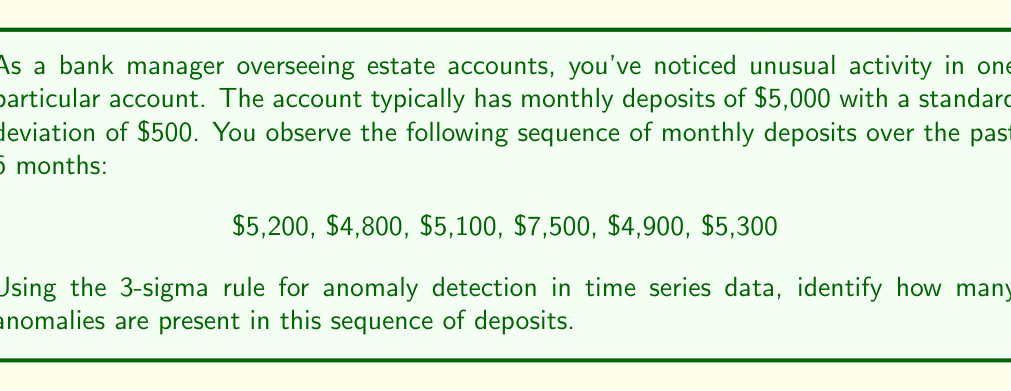Teach me how to tackle this problem. To detect anomalies using the 3-sigma rule in time series data, we follow these steps:

1) Calculate the mean ($\mu$) of the typical monthly deposits:
   $\mu = \$5,000$

2) We're given the standard deviation ($\sigma$) of typical deposits:
   $\sigma = \$500$

3) Calculate the upper and lower bounds for non-anomalous data:
   Upper bound: $\mu + 3\sigma = 5000 + 3(500) = \$6,500$
   Lower bound: $\mu - 3\sigma = 5000 - 3(500) = \$3,500$

4) Any data point outside these bounds is considered an anomaly.

5) Examine each deposit:
   $5,200: 3500 < 5200 < 6500$ (Not an anomaly)
   $4,800: 3500 < 4800 < 6500$ (Not an anomaly)
   $5,100: 3500 < 5100 < 6500$ (Not an anomaly)
   $7,500: 7500 > 6500$ (Anomaly)
   $4,900: 3500 < 4900 < 6500$ (Not an anomaly)
   $5,300: 3500 < 5300 < 6500$ (Not an anomaly)

6) Count the number of anomalies detected.
Answer: 1 anomaly 